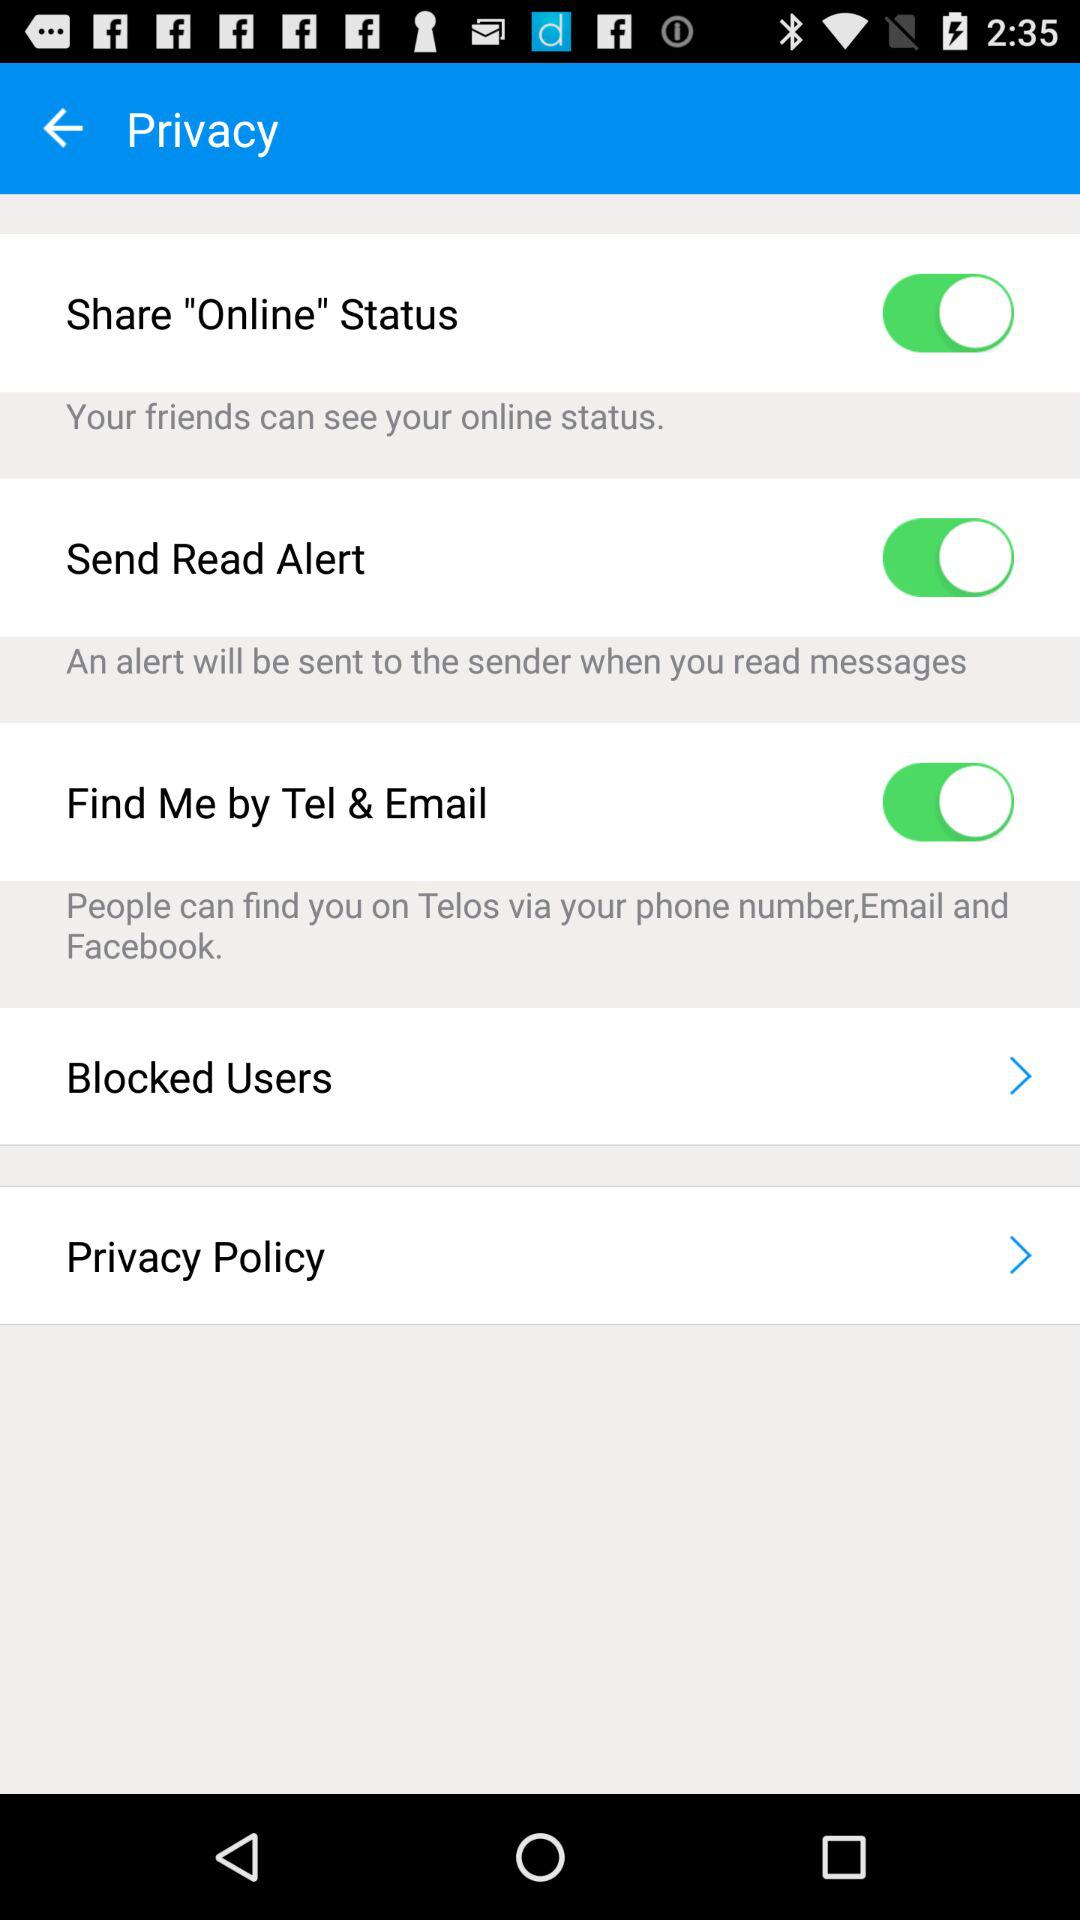What is the status of the "Share "Online" Status"? The status is "on". 